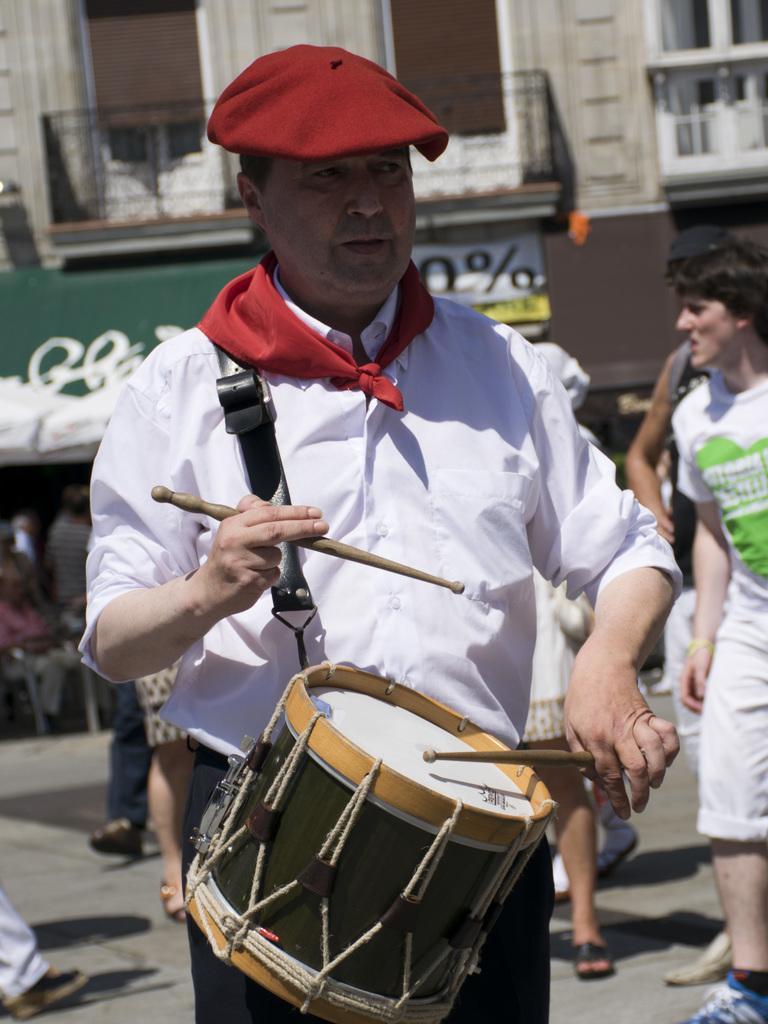Could you give a brief overview of what you see in this image? In this picture we can see man wore red color cap, scarf to his neck and playing drums and in the background we can see building with windows, balcony and some persons walking. 